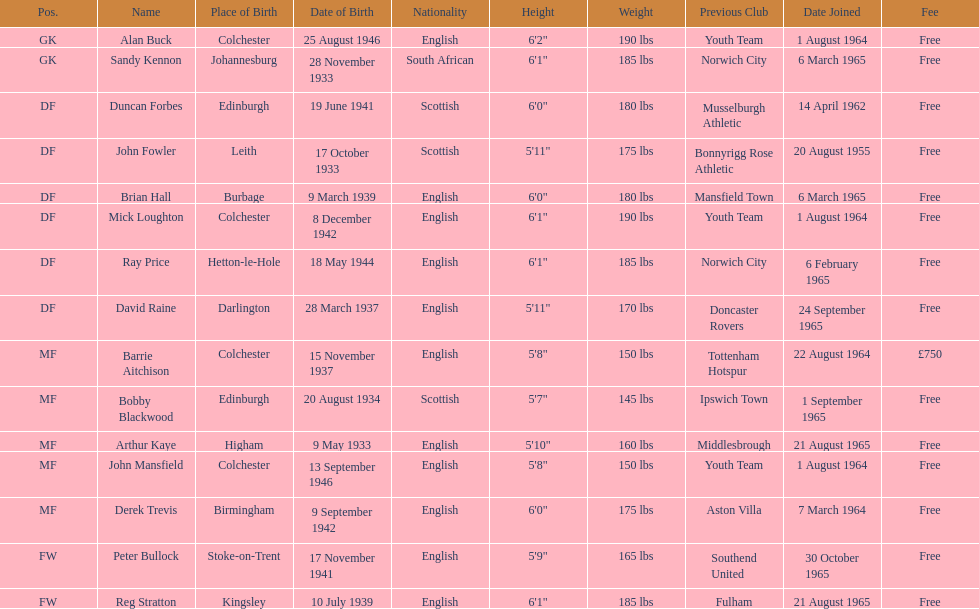Name the player whose fee was not free. Barrie Aitchison. 